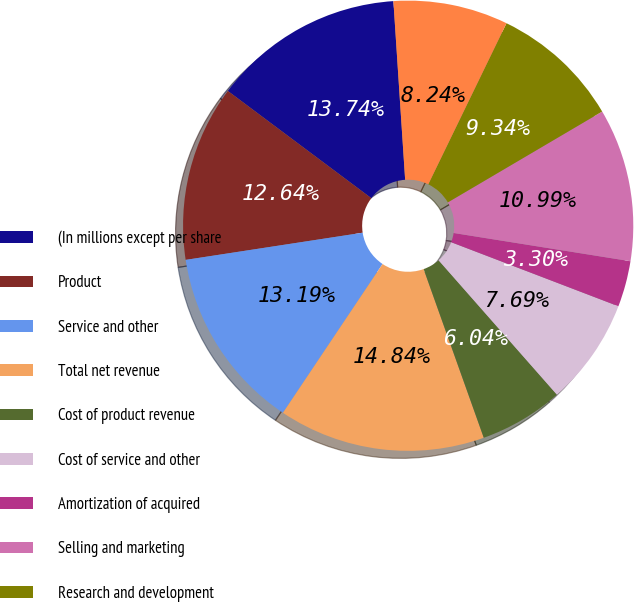<chart> <loc_0><loc_0><loc_500><loc_500><pie_chart><fcel>(In millions except per share<fcel>Product<fcel>Service and other<fcel>Total net revenue<fcel>Cost of product revenue<fcel>Cost of service and other<fcel>Amortization of acquired<fcel>Selling and marketing<fcel>Research and development<fcel>General and administrative<nl><fcel>13.74%<fcel>12.64%<fcel>13.19%<fcel>14.84%<fcel>6.04%<fcel>7.69%<fcel>3.3%<fcel>10.99%<fcel>9.34%<fcel>8.24%<nl></chart> 